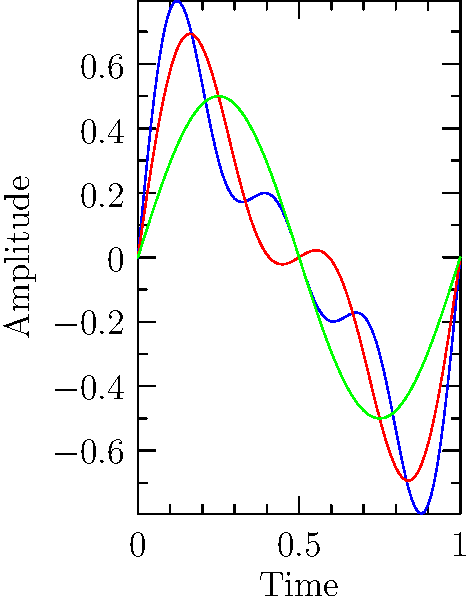Given the waveforms representing audio signals at different bitrates, which characteristic best indicates the higher quality (blue) waveform compared to the lower quality (green) waveform? To analyze the differences between the high-quality (blue) and low-quality (green) waveforms, let's follow these steps:

1. Observe the overall shape: The blue waveform has more complex patterns and variations compared to the green waveform.

2. Frequency content:
   - The blue waveform contains higher frequency components, visible as smaller, faster oscillations superimposed on the main wave.
   - The green waveform only shows the fundamental frequency (the largest, slowest oscillation).

3. Detail preservation:
   - The blue waveform preserves more subtle details and nuances in the audio signal.
   - The green waveform is a simplified representation, lacking the finer details.

4. Dynamic range:
   - The blue waveform exhibits a wider range of amplitudes, potentially representing a broader dynamic range.
   - The green waveform has a more limited range of amplitudes.

5. Harmonics:
   - The blue waveform includes harmonic content (multiples of the fundamental frequency), creating a richer sound.
   - The green waveform lacks these harmonics, resulting in a more basic tone.

The key characteristic that best indicates the higher quality of the blue waveform is the presence of higher frequency components. These components contribute to the increased detail, broader frequency spectrum, and overall richness of the audio signal, which are typically associated with higher bitrates and better audio quality.
Answer: Presence of higher frequency components 